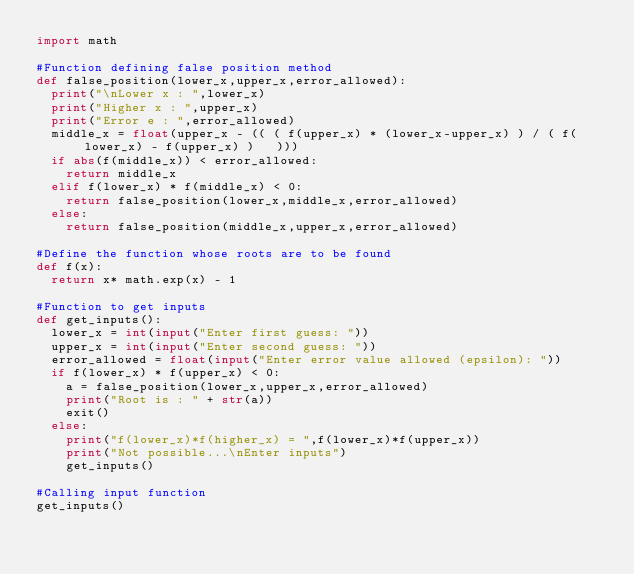Convert code to text. <code><loc_0><loc_0><loc_500><loc_500><_Python_>import math

#Function defining false position method
def false_position(lower_x,upper_x,error_allowed):
  print("\nLower x : ",lower_x)
  print("Higher x : ",upper_x)
  print("Error e : ",error_allowed)
  middle_x = float(upper_x - (( ( f(upper_x) * (lower_x-upper_x) ) / ( f(lower_x) - f(upper_x) )   )))
  if abs(f(middle_x)) < error_allowed:
    return middle_x
  elif f(lower_x) * f(middle_x) < 0:
    return false_position(lower_x,middle_x,error_allowed)
  else:
    return false_position(middle_x,upper_x,error_allowed)

#Define the function whose roots are to be found
def f(x):
  return x* math.exp(x) - 1

#Function to get inputs
def get_inputs():
  lower_x = int(input("Enter first guess: "))
  upper_x = int(input("Enter second guess: "))
  error_allowed = float(input("Enter error value allowed (epsilon): "))
  if f(lower_x) * f(upper_x) < 0:
    a = false_position(lower_x,upper_x,error_allowed)
    print("Root is : " + str(a))
    exit()
  else:
    print("f(lower_x)*f(higher_x) = ",f(lower_x)*f(upper_x))
    print("Not possible...\nEnter inputs")
    get_inputs()

#Calling input function
get_inputs()</code> 